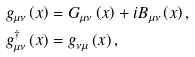Convert formula to latex. <formula><loc_0><loc_0><loc_500><loc_500>g _ { \mu \nu } \left ( x \right ) & = G _ { \mu \nu } \left ( x \right ) + i B _ { \mu \nu } \left ( x \right ) , \\ g _ { \mu \nu } ^ { \dagger } \left ( x \right ) & = g _ { \nu \mu } \left ( x \right ) ,</formula> 